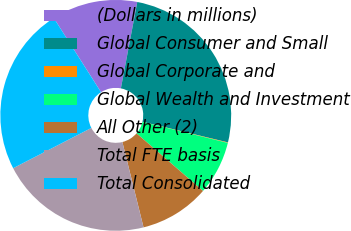<chart> <loc_0><loc_0><loc_500><loc_500><pie_chart><fcel>(Dollars in millions)<fcel>Global Consumer and Small<fcel>Global Corporate and<fcel>Global Wealth and Investment<fcel>All Other (2)<fcel>Total FTE basis<fcel>Total Consolidated<nl><fcel>12.01%<fcel>25.78%<fcel>0.07%<fcel>7.52%<fcel>9.77%<fcel>21.3%<fcel>23.54%<nl></chart> 